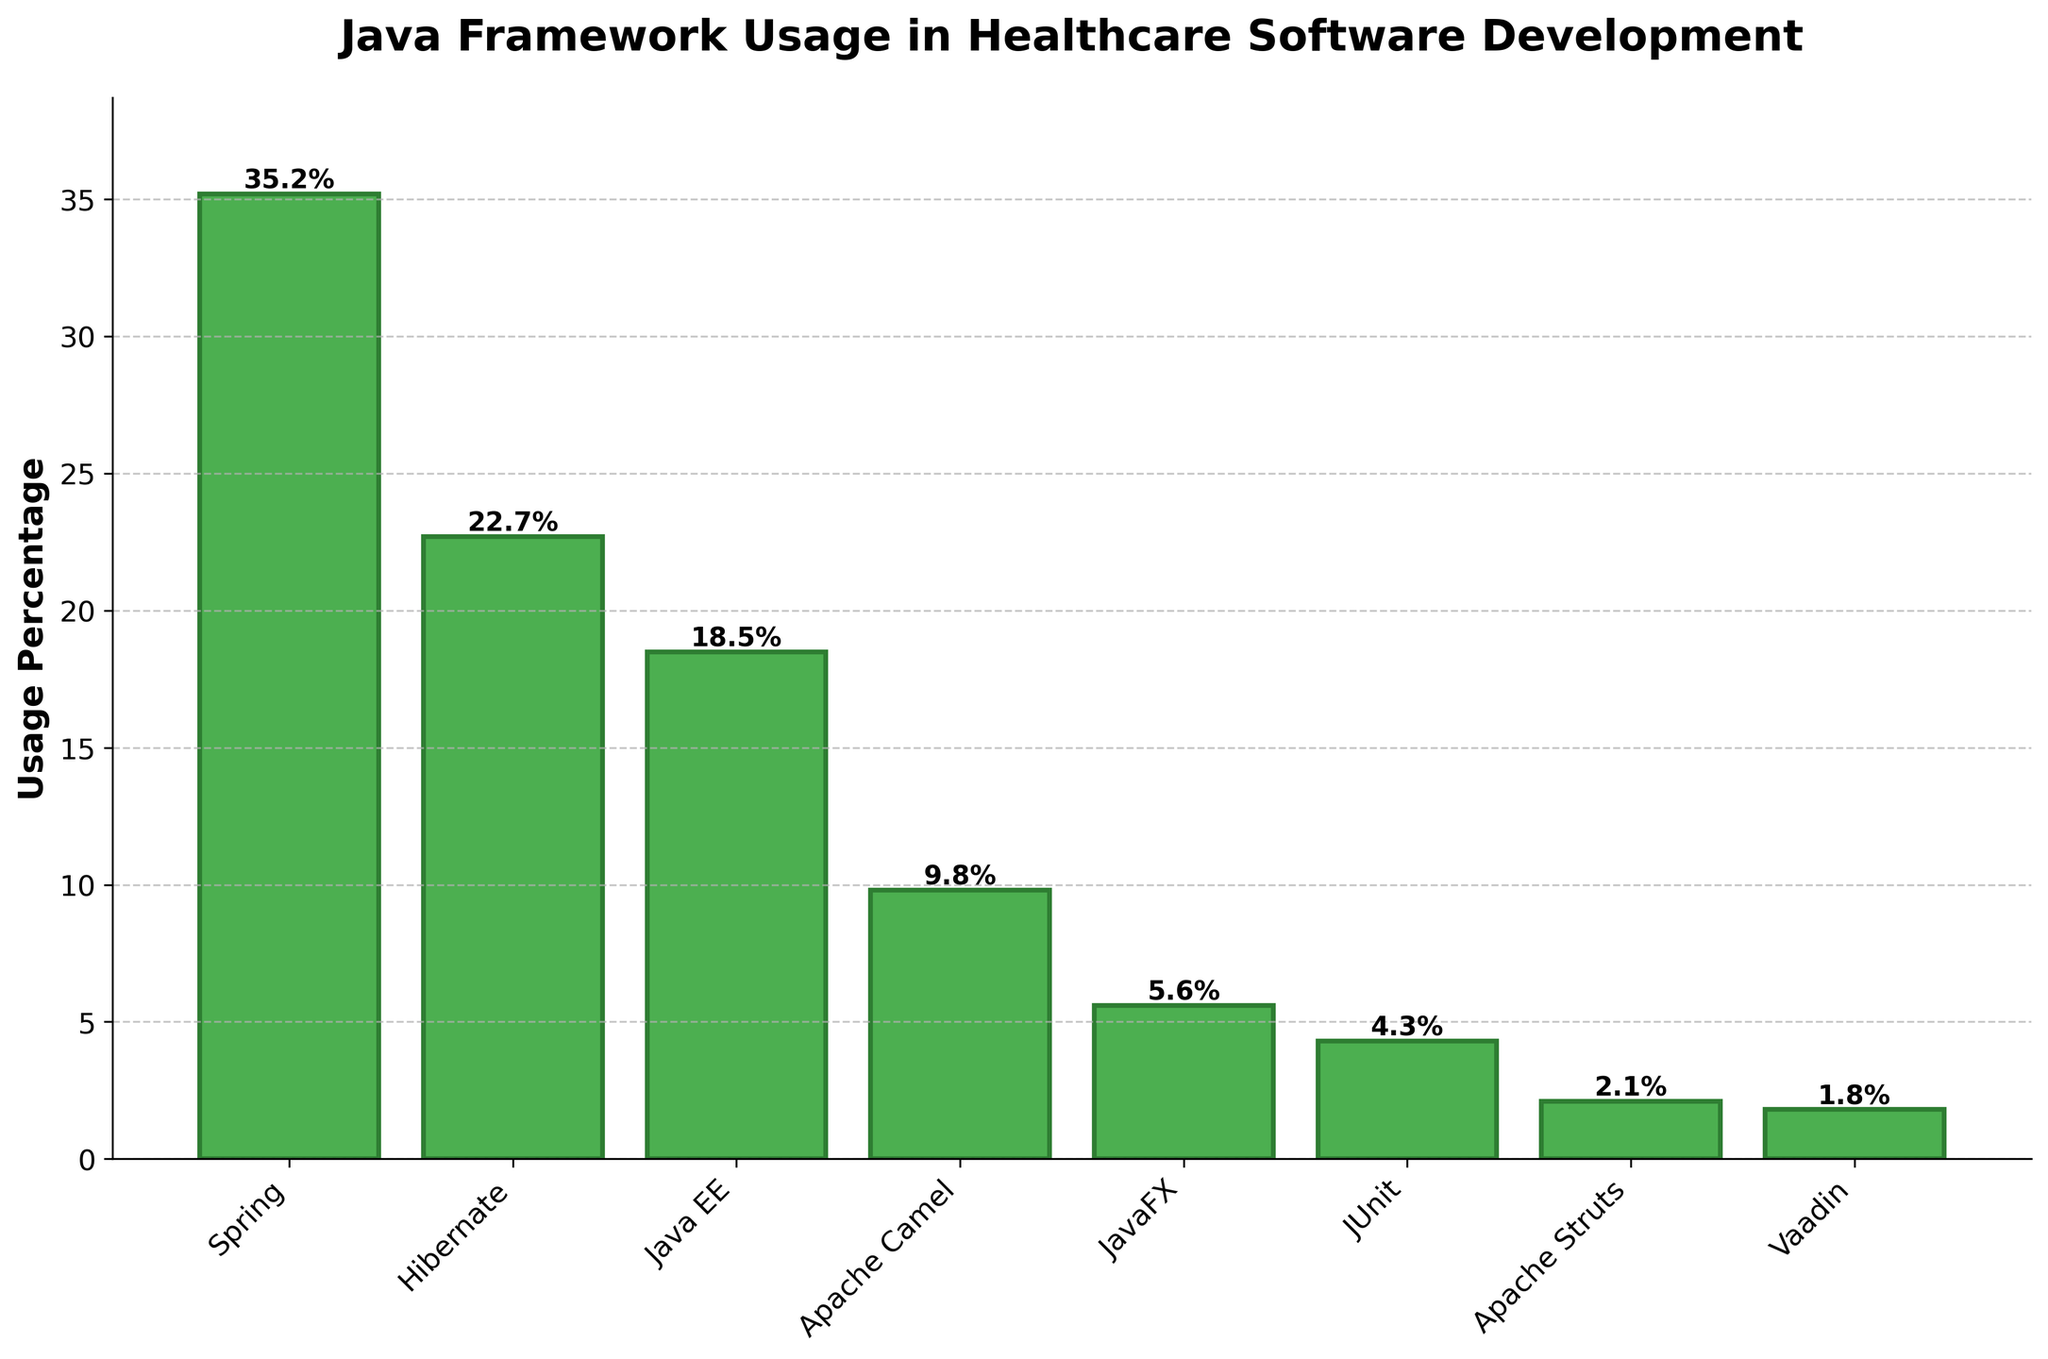what is the most used Java framework in healthcare software development? By observing the heights of the bars, the Spring framework has the highest bar, indicating it has the most significant usage percentage.
Answer: Spring Which framework has a usage percentage closest to 10%? By examining the heights and the given numerical values, Apache Camel has a usage percentage closest to 10%, with 9.8%.
Answer: Apache Camel What is the combined usage percentage for Spring and Hibernate? Add the usage percentages of Spring (35.2%) and Hibernate (22.7%). 35.2 + 22.7 = 57.9%
Answer: 57.9% Which two frameworks have the smallest usage percentages? By comparing the heights of the bars, Vaadin (1.8%) and Apache Struts (2.1%) have the smallest usage percentages.
Answer: Vaadin and Apache Struts How much more is the usage percentage of Java EE compared to JavaFX? Subtract the usage percentage of JavaFX (5.6%) from Java EE (18.5%). 18.5 - 5.6 = 12.9%
Answer: 12.9% If you combine the usage percentages of Java EE and Apache Camel, how does it compare to the usage percentage of Spring? Combine the usage percentages of Java EE (18.5%) and Apache Camel (9.8%), which gives 18.5 + 9.8 = 28.3%. Compare this with Spring's usage percentage of 35.2. 35.2% is higher than 28.3%.
Answer: Spring's usage is higher What is the average usage percentage of Apache Camel, JavaFX, and JUnit? Sum the usage percentages of Apache Camel (9.8%), JavaFX (5.6%), and JUnit (4.3%). 9.8 + 5.6 + 4.3 = 19.7. Divide by 3 to get the average. 19.7 / 3 ≈ 6.57%
Answer: 6.57% Visually, which bar is the shortest and what does it represent? The shortest bar represents Vaadin with a usage percentage of 1.8%.
Answer: Vaadin What is the difference between the highest and the lowest usage percentages shown in the bar chart? The highest usage percentage is Spring with 35.2%, and the lowest is Vaadin with 1.8%. Subtract the lowest from the highest: 35.2 - 1.8 = 33.4%
Answer: 33.4% How many frameworks have a usage percentage above 10%? By comparing the heights of the bars, the frameworks with usage percentages above 10% are Spring (35.2%), Hibernate (22.7%), and Java EE (18.5%). There are three such frameworks.
Answer: Three 